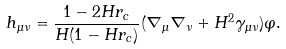<formula> <loc_0><loc_0><loc_500><loc_500>h _ { \mu \nu } = \frac { 1 - 2 H r _ { c } } { H ( 1 - H r _ { c } ) } ( \nabla _ { \mu } \nabla _ { \nu } + H ^ { 2 } \gamma _ { \mu \nu } ) \varphi .</formula> 